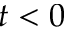Convert formula to latex. <formula><loc_0><loc_0><loc_500><loc_500>t < 0</formula> 